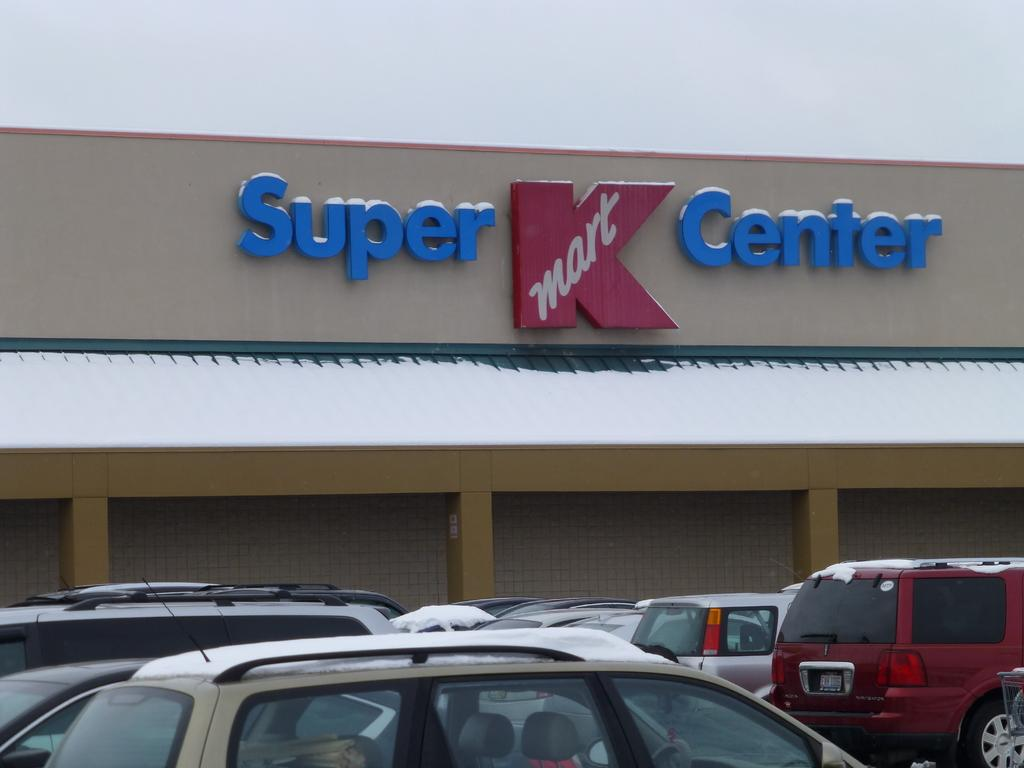What type of vehicles can be seen in the image? There are cars in the image. What architectural features are present in the image? There are pillars and walls in the image. What type of signage is visible in the image? There is a letters board in the image. What is visible in the background of the image? The sky is visible in the background of the image. Can you tell me how many owls are perched on the pillars in the image? There are no owls present in the image; it only features cars, pillars, walls, a letters board, and the sky. What year is depicted on the letters board in the image? The provided facts do not mention any specific year on the letters board, so it cannot be determined from the image. 